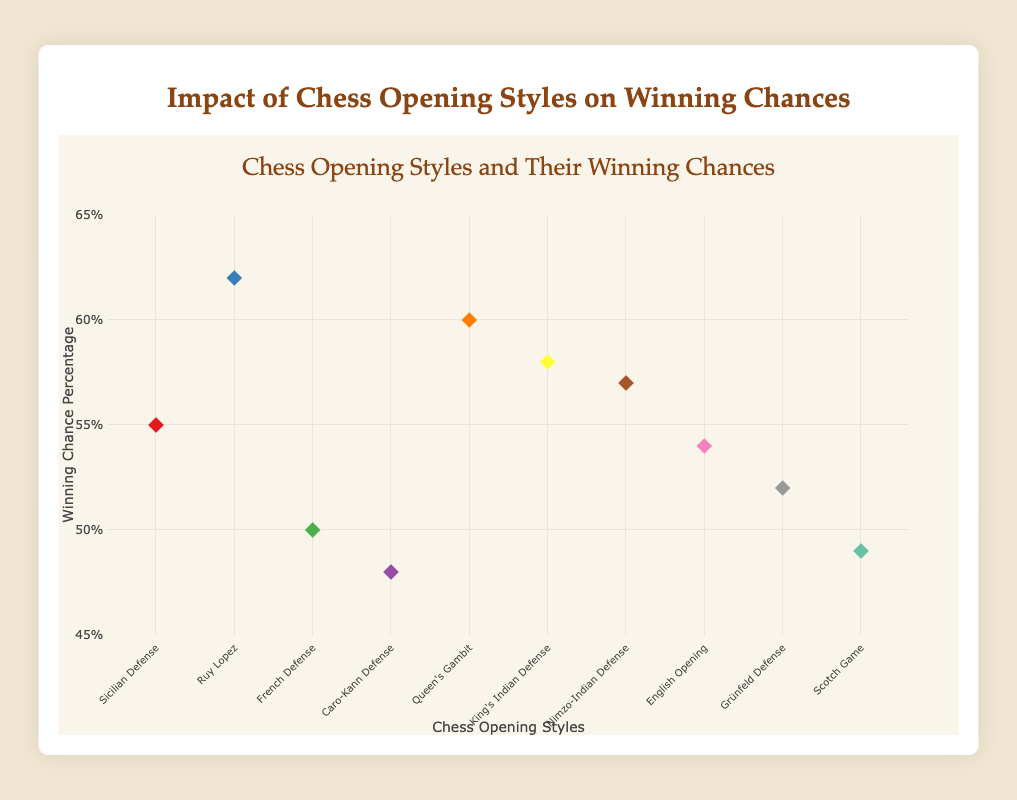What's the title of the chart? The title is located at the top of the chart and provides an overall description of what the chart is about.
Answer: Impact of Chess Opening Styles on Winning Chances What's the range of the y-axis? The y-axis, which represents the winning chance percentage, has its range specified.
Answer: 45% to 65% How many chess opening styles are presented in the chart? Count all distinct labels on the x-axis; each represents a different chess opening style.
Answer: 10 What opening style has the highest winning chance? Look for the data point with the highest y-value.
Answer: Ruy Lopez What's the winning chance percentage of the Sicilian Defense? Identify the data point labeled "Sicilian Defense" on the x-axis and read its corresponding y-value.
Answer: 55% What is the average winning chance percentage of all chess openings? Add up all winning percentages and divide by the number of opening styles (55 + 62 + 50 + 48 + 60 + 58 + 57 + 54 + 52 + 49) / 10.
Answer: 54.5% How does the winning chance of the French Defense compare to the Caro-Kann Defense? Read and compare the y-values for both the French Defense and the Caro-Kann Defense.
Answer: French Defense has a higher winning chance than Caro-Kann Defense Which opening style is represented with the color red? Refer to the legend or recognize color coding of markers.
Answer: Sicilian Defense What is the difference in winning chance percentage between Queen's Gambit and Scotch Game? Subtract the winning percentage of Scotch Game from that of Queen's Gambit (60% - 49%).
Answer: 11% How many opening styles have a winning percentage above 55%? Count the number of data points with y-values greater than 55%.
Answer: 5 